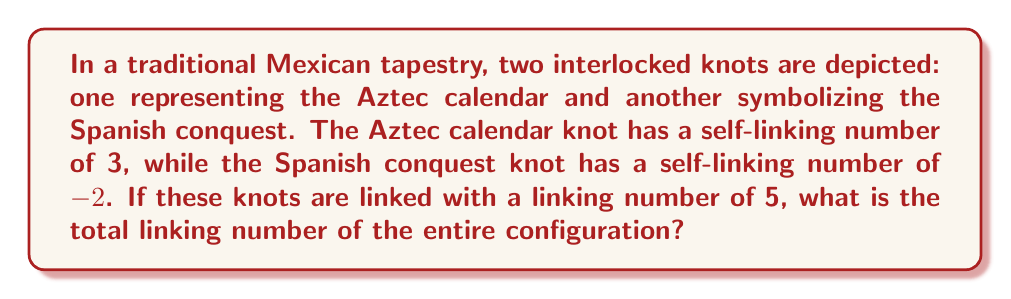Give your solution to this math problem. To solve this problem, we need to understand the concept of linking numbers in knot theory and how they apply to Mexican folk art designs. Let's break it down step-by-step:

1. Self-linking numbers:
   - Aztec calendar knot: $L_1 = 3$
   - Spanish conquest knot: $L_2 = -2$

2. Linking number between the two knots: $L_{12} = 5$

3. The total linking number of a configuration with two knots is calculated using the formula:

   $$ L_{total} = L_1 + L_2 + 2L_{12} $$

   Where $L_1$ and $L_2$ are the self-linking numbers of the individual knots, and $L_{12}$ is the linking number between the two knots.

4. Substituting the given values into the formula:

   $$ L_{total} = 3 + (-2) + 2(5) $$

5. Simplifying:

   $$ L_{total} = 3 - 2 + 10 = 11 $$

Therefore, the total linking number of the entire configuration in the Mexican tapestry is 11.
Answer: 11 